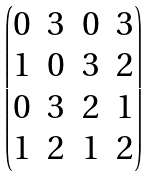<formula> <loc_0><loc_0><loc_500><loc_500>\begin{pmatrix} 0 & 3 & 0 & 3 \\ 1 & 0 & 3 & 2 \\ 0 & 3 & 2 & 1 \\ 1 & 2 & 1 & 2 \end{pmatrix}</formula> 